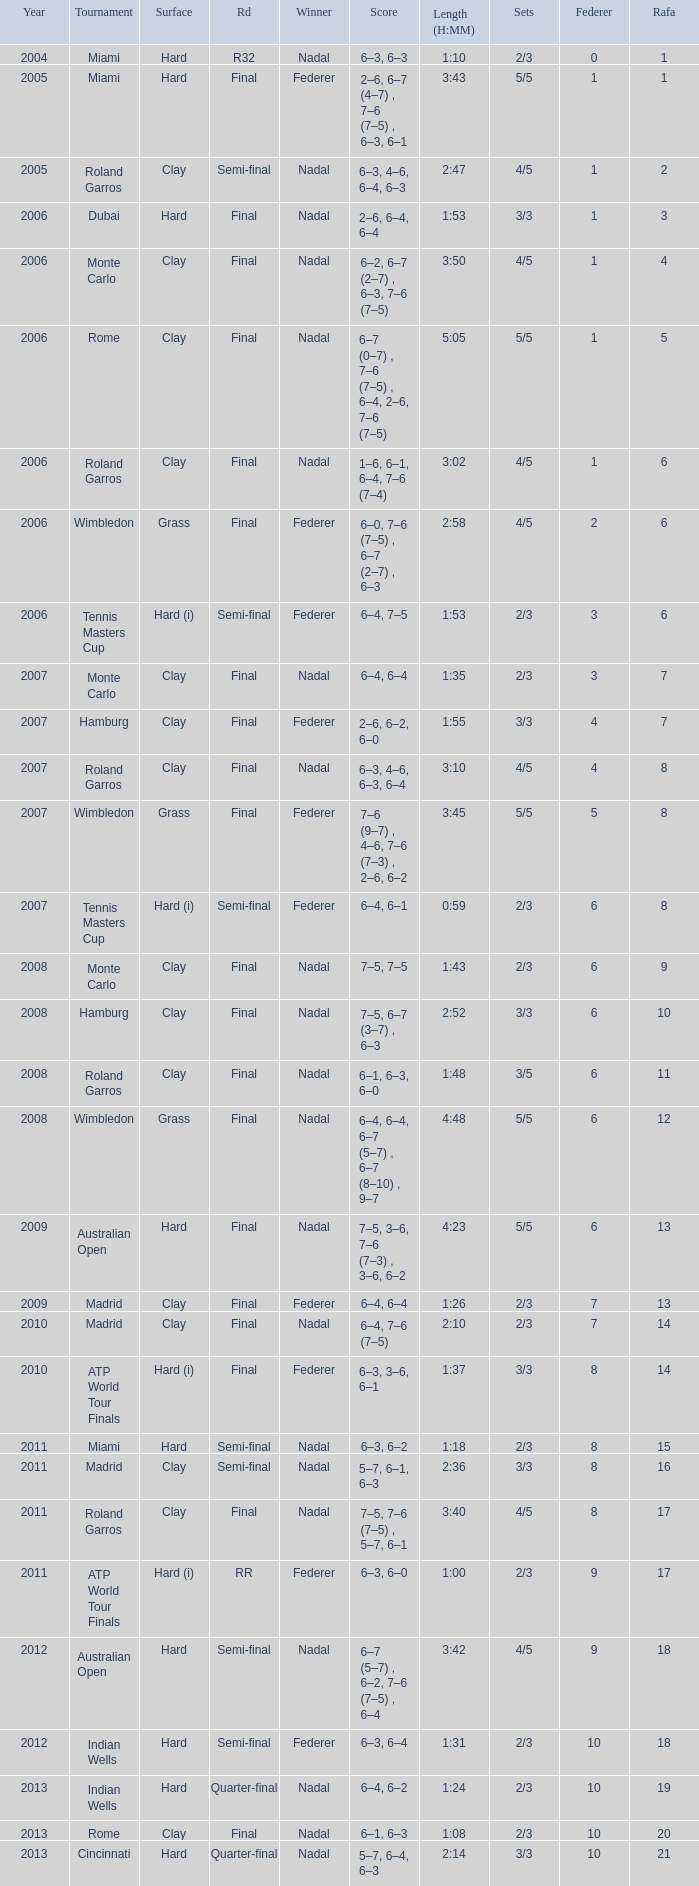What were the sets when Federer had 6 and a nadal of 13? 5/5. 